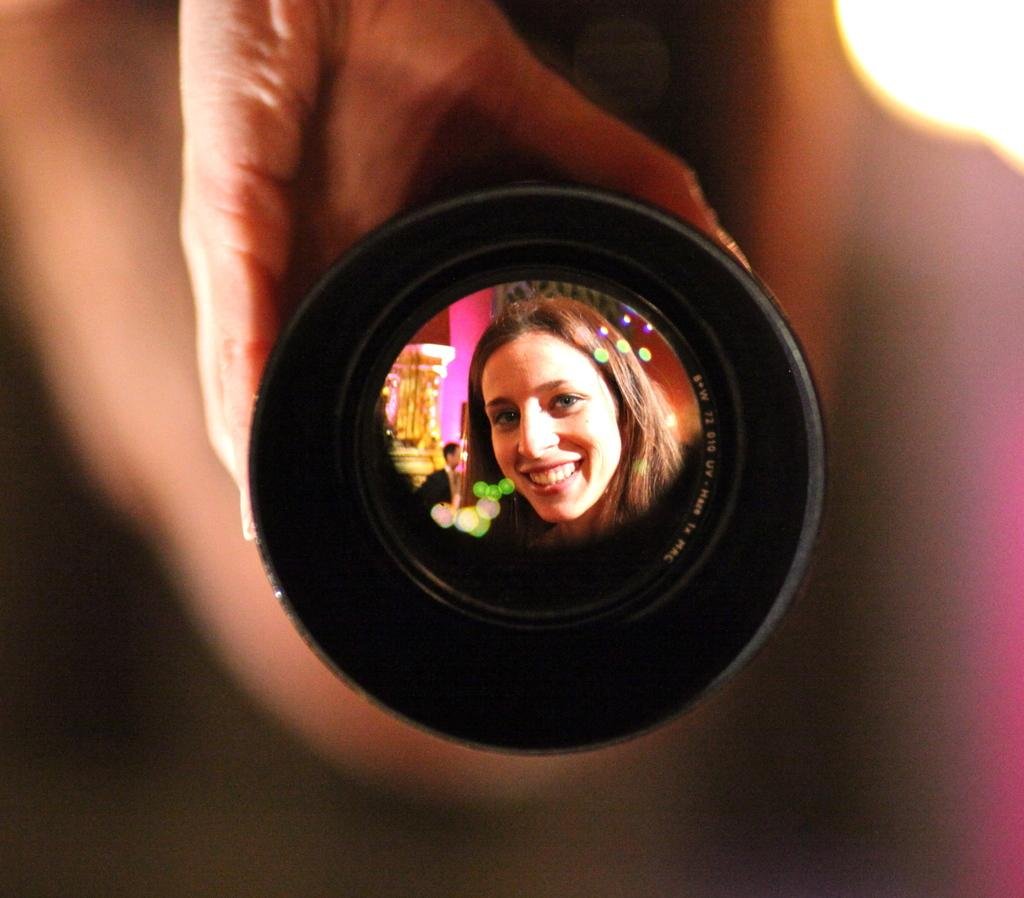What is the human hand holding in the image? There is a device being held by a human hand in the image. Can you describe the facial expression of the woman in the image? The woman in the image is smiling. What is the man wearing in the image? The man in the image is wearing clothes. What can be seen providing illumination in the image? There is a light visible in the image. What type of oatmeal is the crow eating in the image? There is no crow or oatmeal present in the image. What thrilling activity is the man participating in while wearing clothes? The provided facts do not mention any specific activity or thrill, so we cannot determine what the man might be doing. 